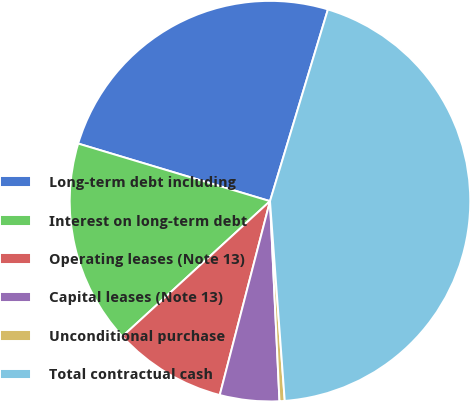Convert chart to OTSL. <chart><loc_0><loc_0><loc_500><loc_500><pie_chart><fcel>Long-term debt including<fcel>Interest on long-term debt<fcel>Operating leases (Note 13)<fcel>Capital leases (Note 13)<fcel>Unconditional purchase<fcel>Total contractual cash<nl><fcel>25.03%<fcel>16.45%<fcel>9.16%<fcel>4.79%<fcel>0.42%<fcel>44.16%<nl></chart> 